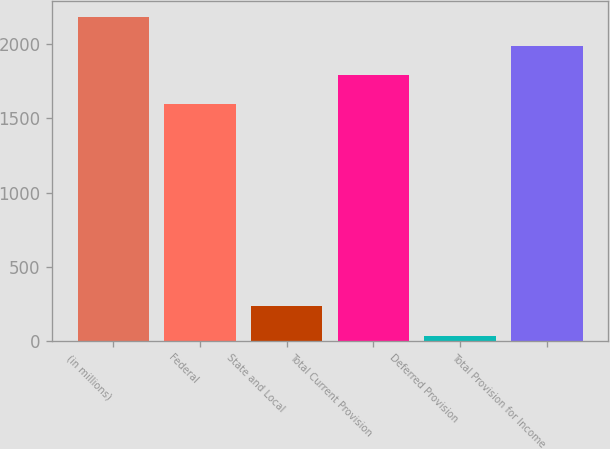Convert chart to OTSL. <chart><loc_0><loc_0><loc_500><loc_500><bar_chart><fcel>(in millions)<fcel>Federal<fcel>State and Local<fcel>Total Current Provision<fcel>Deferred Provision<fcel>Total Provision for Income<nl><fcel>2184.4<fcel>1594<fcel>233.8<fcel>1790.8<fcel>37<fcel>1987.6<nl></chart> 